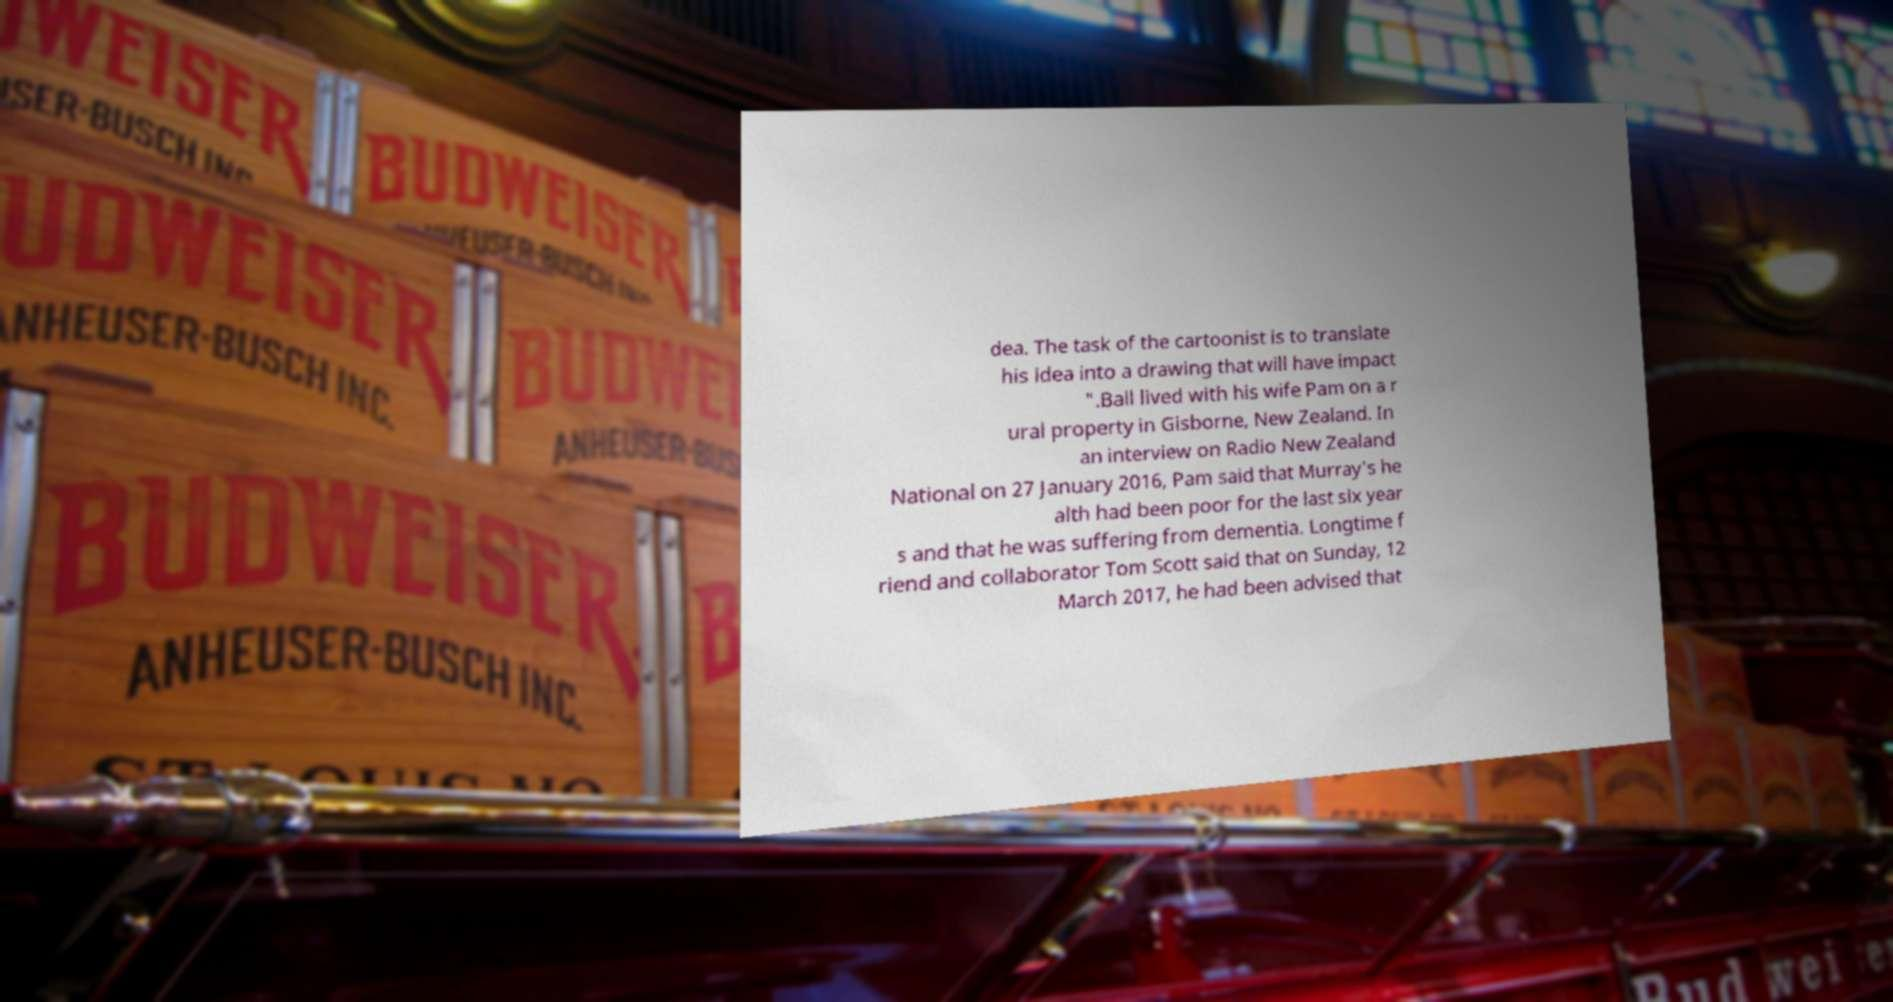For documentation purposes, I need the text within this image transcribed. Could you provide that? dea. The task of the cartoonist is to translate his idea into a drawing that will have impact ".Ball lived with his wife Pam on a r ural property in Gisborne, New Zealand. In an interview on Radio New Zealand National on 27 January 2016, Pam said that Murray's he alth had been poor for the last six year s and that he was suffering from dementia. Longtime f riend and collaborator Tom Scott said that on Sunday, 12 March 2017, he had been advised that 